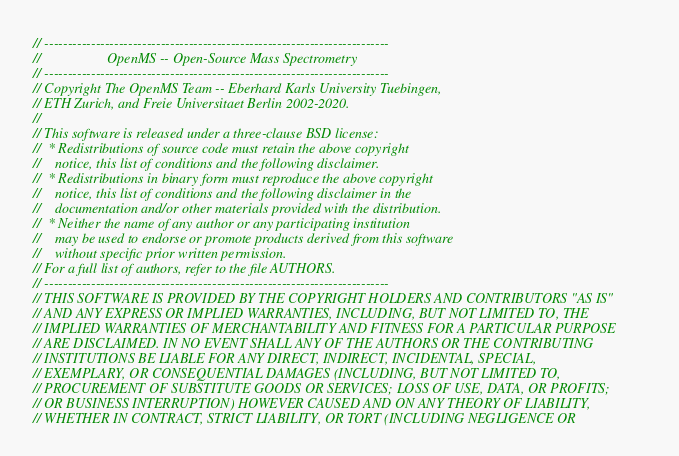<code> <loc_0><loc_0><loc_500><loc_500><_C_>// --------------------------------------------------------------------------
//                   OpenMS -- Open-Source Mass Spectrometry
// --------------------------------------------------------------------------
// Copyright The OpenMS Team -- Eberhard Karls University Tuebingen,
// ETH Zurich, and Freie Universitaet Berlin 2002-2020.
//
// This software is released under a three-clause BSD license:
//  * Redistributions of source code must retain the above copyright
//    notice, this list of conditions and the following disclaimer.
//  * Redistributions in binary form must reproduce the above copyright
//    notice, this list of conditions and the following disclaimer in the
//    documentation and/or other materials provided with the distribution.
//  * Neither the name of any author or any participating institution
//    may be used to endorse or promote products derived from this software
//    without specific prior written permission.
// For a full list of authors, refer to the file AUTHORS.
// --------------------------------------------------------------------------
// THIS SOFTWARE IS PROVIDED BY THE COPYRIGHT HOLDERS AND CONTRIBUTORS "AS IS"
// AND ANY EXPRESS OR IMPLIED WARRANTIES, INCLUDING, BUT NOT LIMITED TO, THE
// IMPLIED WARRANTIES OF MERCHANTABILITY AND FITNESS FOR A PARTICULAR PURPOSE
// ARE DISCLAIMED. IN NO EVENT SHALL ANY OF THE AUTHORS OR THE CONTRIBUTING
// INSTITUTIONS BE LIABLE FOR ANY DIRECT, INDIRECT, INCIDENTAL, SPECIAL,
// EXEMPLARY, OR CONSEQUENTIAL DAMAGES (INCLUDING, BUT NOT LIMITED TO,
// PROCUREMENT OF SUBSTITUTE GOODS OR SERVICES; LOSS OF USE, DATA, OR PROFITS;
// OR BUSINESS INTERRUPTION) HOWEVER CAUSED AND ON ANY THEORY OF LIABILITY,
// WHETHER IN CONTRACT, STRICT LIABILITY, OR TORT (INCLUDING NEGLIGENCE OR</code> 